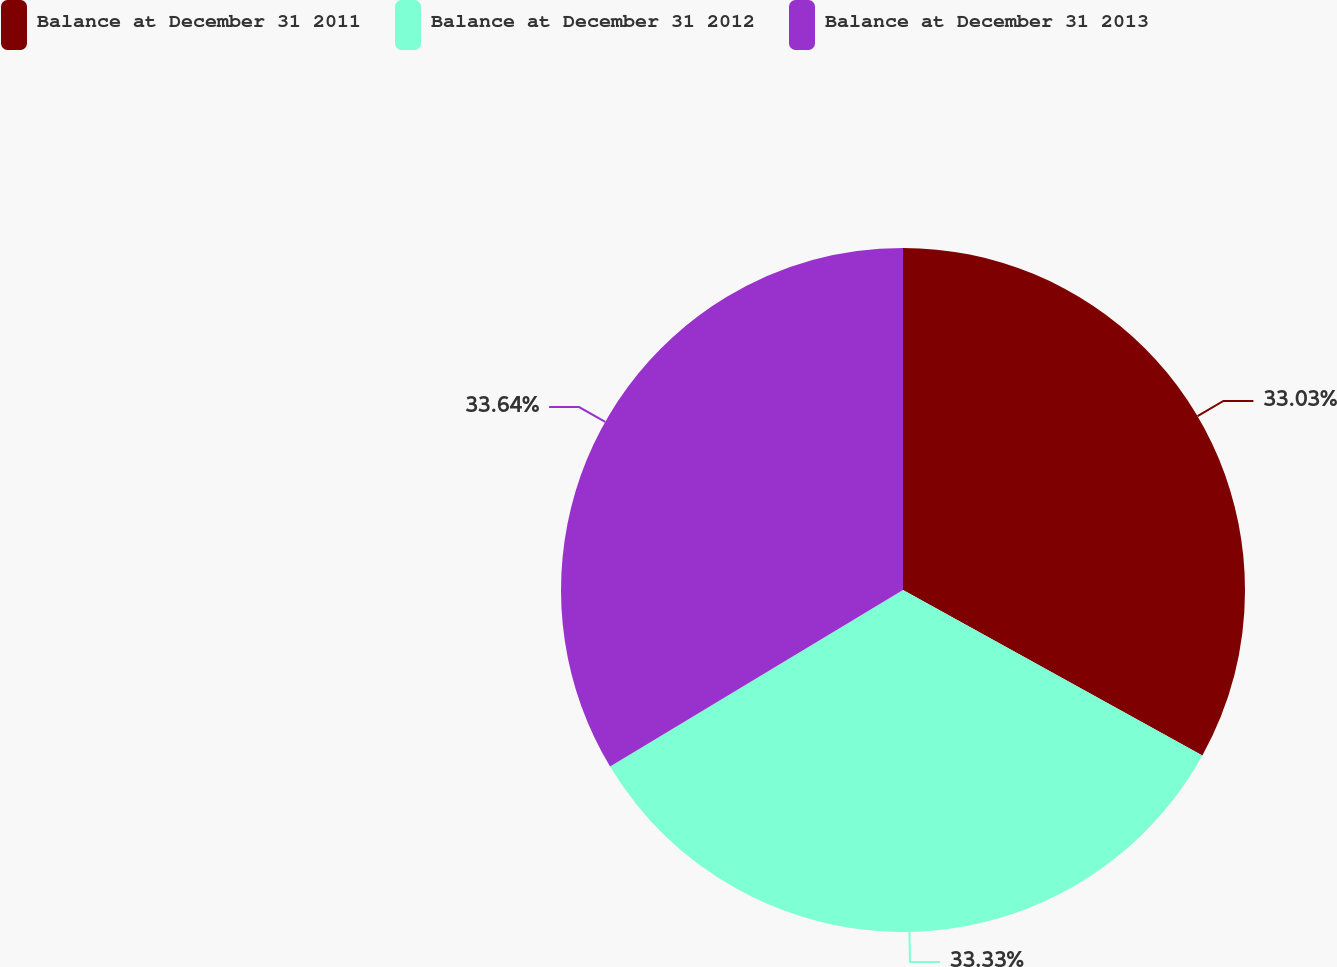Convert chart. <chart><loc_0><loc_0><loc_500><loc_500><pie_chart><fcel>Balance at December 31 2011<fcel>Balance at December 31 2012<fcel>Balance at December 31 2013<nl><fcel>33.03%<fcel>33.33%<fcel>33.63%<nl></chart> 